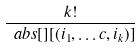<formula> <loc_0><loc_0><loc_500><loc_500>\frac { k ! } { \ a b s [ ] { [ ( i _ { 1 } , \dots c , i _ { k } ) ] } }</formula> 